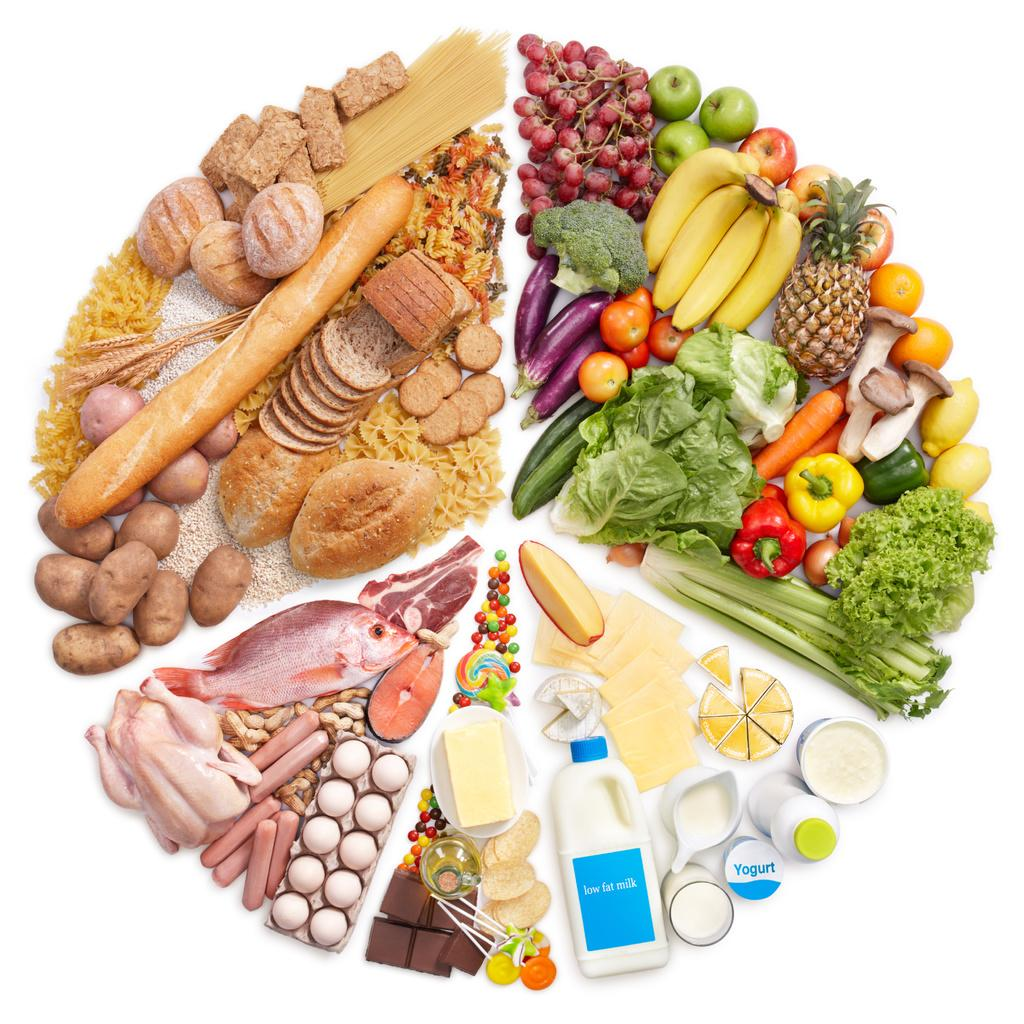What type of food items are featured in the image? There are diet food items in the image, including vegetables, fruits, and milk products. Can you describe the specific diet food items that are visible? Besides vegetables, fruits, and milk products, there are other diet food items present in the image. How many different types of diet food items can be seen in the image? It is not possible to determine the exact number of different types of diet food items from the provided facts, but there are at least four types mentioned: vegetables, fruits, milk products, and other diet food items. How many friends are sitting on the oranges in the image? There are no oranges or friends present in the image. What type of test is being conducted with the diet food items in the image? There is no indication of a test being conducted with the diet food items in the image. 